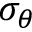Convert formula to latex. <formula><loc_0><loc_0><loc_500><loc_500>\sigma _ { \theta }</formula> 